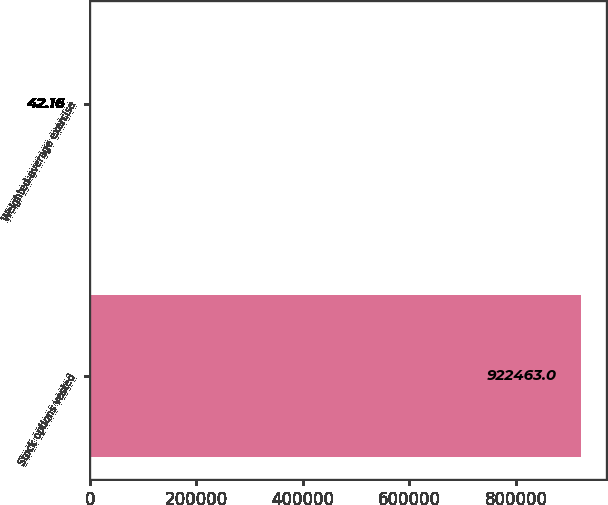Convert chart. <chart><loc_0><loc_0><loc_500><loc_500><bar_chart><fcel>Stock options vested<fcel>Weighted-average exercise<nl><fcel>922463<fcel>42.16<nl></chart> 